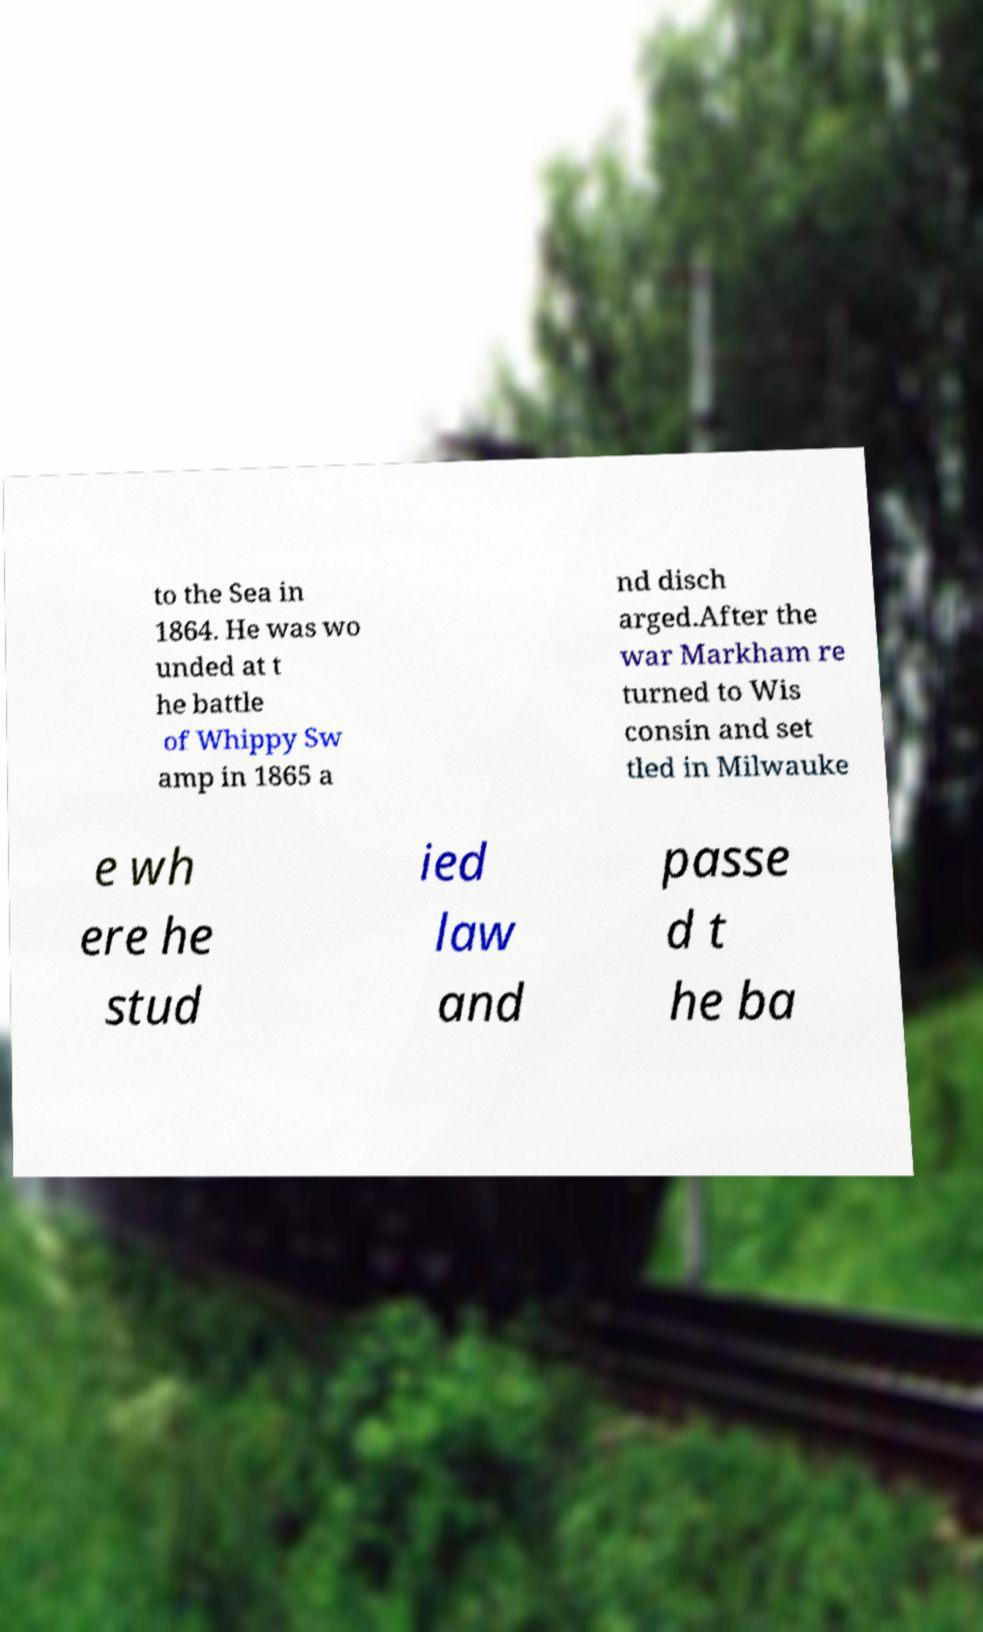Can you accurately transcribe the text from the provided image for me? to the Sea in 1864. He was wo unded at t he battle of Whippy Sw amp in 1865 a nd disch arged.After the war Markham re turned to Wis consin and set tled in Milwauke e wh ere he stud ied law and passe d t he ba 